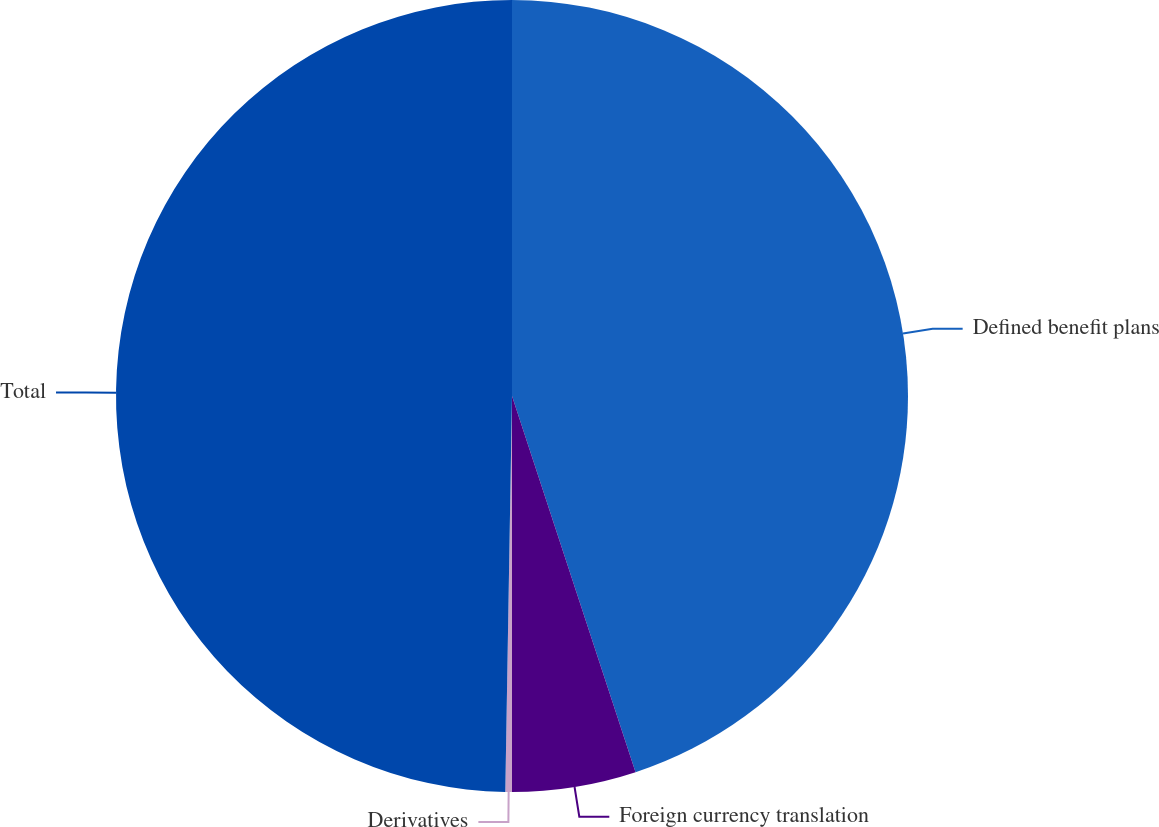<chart> <loc_0><loc_0><loc_500><loc_500><pie_chart><fcel>Defined benefit plans<fcel>Foreign currency translation<fcel>Derivatives<fcel>Total<nl><fcel>44.95%<fcel>5.05%<fcel>0.27%<fcel>49.73%<nl></chart> 